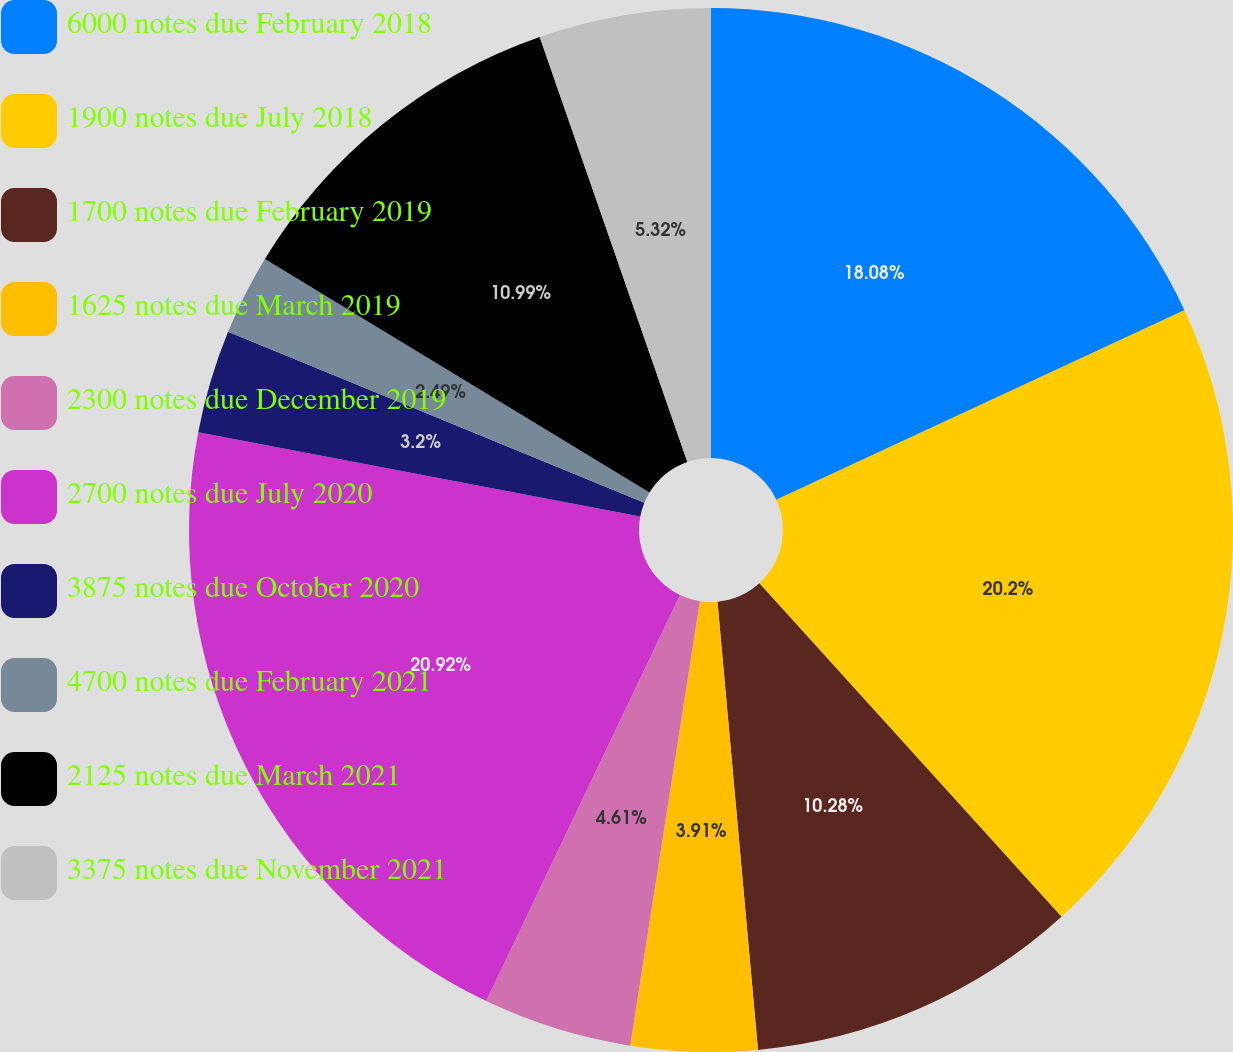<chart> <loc_0><loc_0><loc_500><loc_500><pie_chart><fcel>6000 notes due February 2018<fcel>1900 notes due July 2018<fcel>1700 notes due February 2019<fcel>1625 notes due March 2019<fcel>2300 notes due December 2019<fcel>2700 notes due July 2020<fcel>3875 notes due October 2020<fcel>4700 notes due February 2021<fcel>2125 notes due March 2021<fcel>3375 notes due November 2021<nl><fcel>18.08%<fcel>20.2%<fcel>10.28%<fcel>3.91%<fcel>4.61%<fcel>20.91%<fcel>3.2%<fcel>2.49%<fcel>10.99%<fcel>5.32%<nl></chart> 